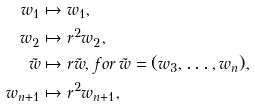<formula> <loc_0><loc_0><loc_500><loc_500>w _ { 1 } & \mapsto w _ { 1 } , \\ w _ { 2 } & \mapsto r ^ { 2 } w _ { 2 } , \\ \tilde { w } & \mapsto r \tilde { w } , \, f o r \, \tilde { w } = ( w _ { 3 } , \dots , w _ { n } ) , \\ w _ { n + 1 } & \mapsto r ^ { 2 } w _ { n + 1 } ,</formula> 